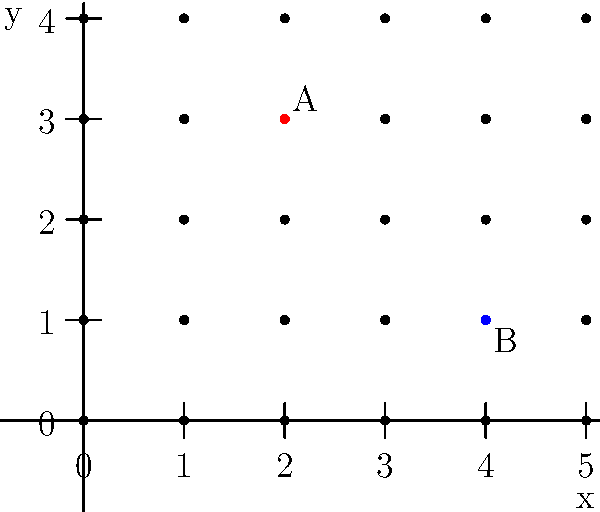In a choir performance, singers are arranged on a stage using a grid system where each point represents a singer's position. If singer A is at coordinates (2,3) and singer B is at (4,1), what is the Manhattan distance between them? (The Manhattan distance is the sum of the absolute differences of their x and y coordinates.) To find the Manhattan distance between two points, we need to:

1. Calculate the absolute difference in x-coordinates:
   $|x_A - x_B| = |2 - 4| = |-2| = 2$

2. Calculate the absolute difference in y-coordinates:
   $|y_A - y_B| = |3 - 1| = |2| = 2$

3. Sum these absolute differences:
   Manhattan distance = $|x_A - x_B| + |y_A - y_B| = 2 + 2 = 4$

The Manhattan distance represents the number of grid steps a singer would need to take to move from one position to the other, moving only horizontally and vertically.
Answer: 4 